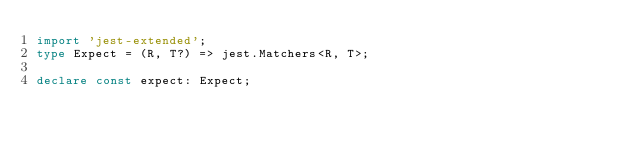Convert code to text. <code><loc_0><loc_0><loc_500><loc_500><_TypeScript_>import 'jest-extended';
type Expect = (R, T?) => jest.Matchers<R, T>;

declare const expect: Expect;</code> 